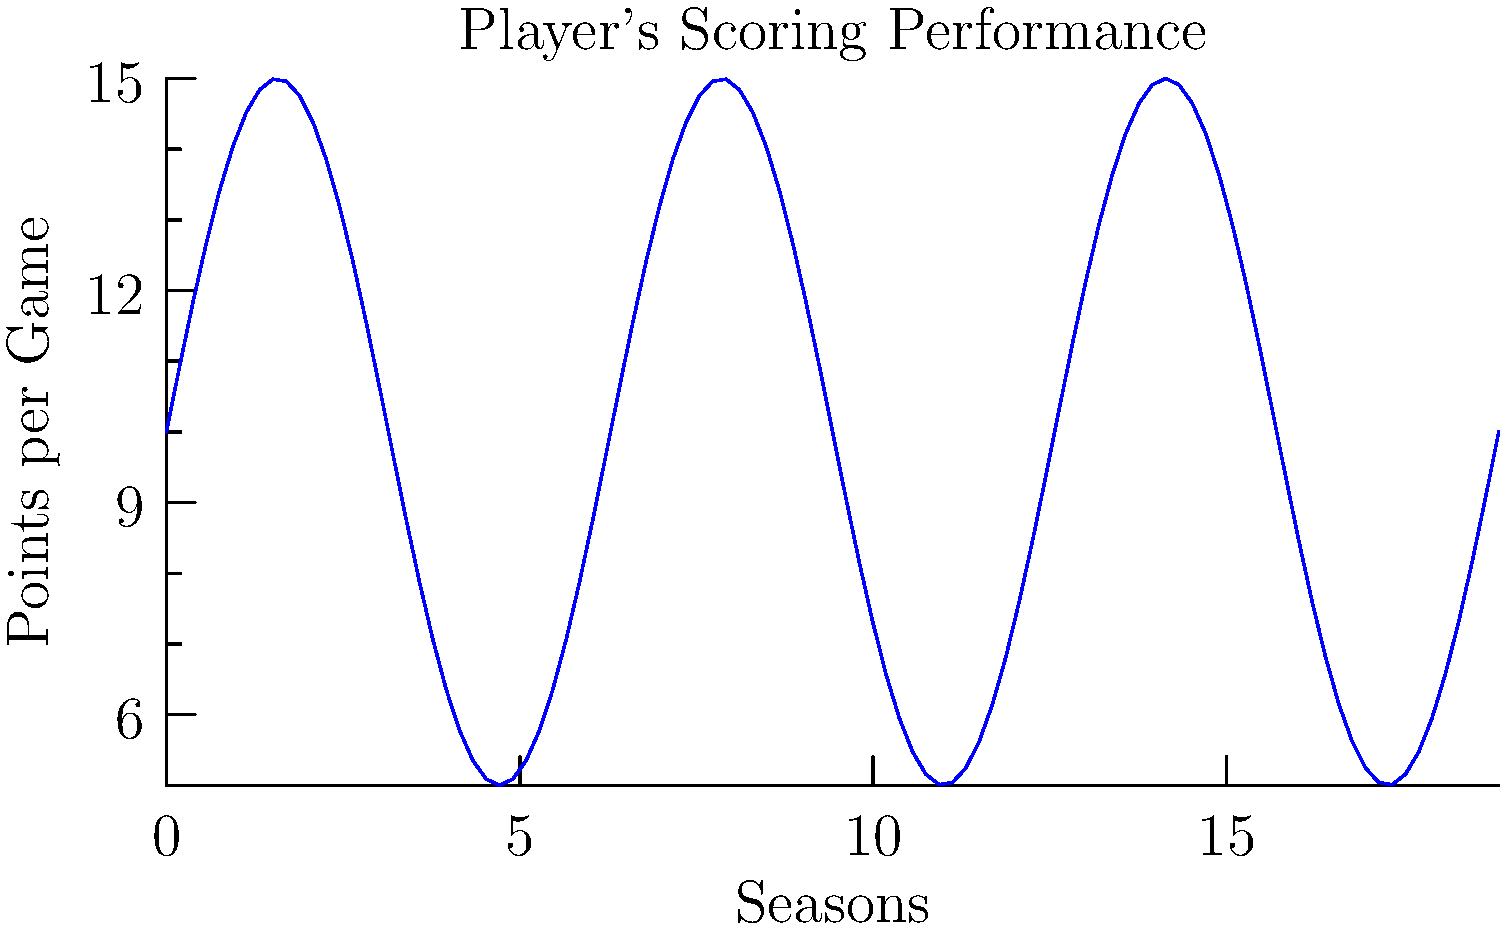The graph represents a player's scoring performance over multiple seasons. The function modeling the player's points per game is given by $f(x) = 10 + 5\sin(x)$, where $x$ represents the season number. Calculate the total points scored by the player over 6 seasons, assuming each season consists of 82 games. To solve this problem, we need to follow these steps:

1) The total points scored over 6 seasons is represented by the area under the curve from $x=0$ to $x=6\pi$ (since one full cycle of the sine function represents one season), multiplied by 82 (the number of games per season).

2) We need to calculate the definite integral of $f(x)$ from 0 to $6\pi$:

   $\int_0^{6\pi} (10 + 5\sin(x)) dx$

3) Let's break this into two parts:
   
   $\int_0^{6\pi} 10 dx + \int_0^{6\pi} 5\sin(x) dx$

4) For the first part:
   $\int_0^{6\pi} 10 dx = 10x |_0^{6\pi} = 60\pi$

5) For the second part:
   $\int_0^{6\pi} 5\sin(x) dx = -5\cos(x) |_0^{6\pi} = -5(\cos(6\pi) - \cos(0)) = 0$

6) Adding these together:
   $60\pi + 0 = 60\pi$

7) This represents the average points per game over 6 seasons. To get the total points, we multiply by 82:

   $60\pi * 82 = 4920\pi \approx 15,455.04$

Therefore, the player scored approximately 15,455 points over 6 seasons.
Answer: 15,455 points 